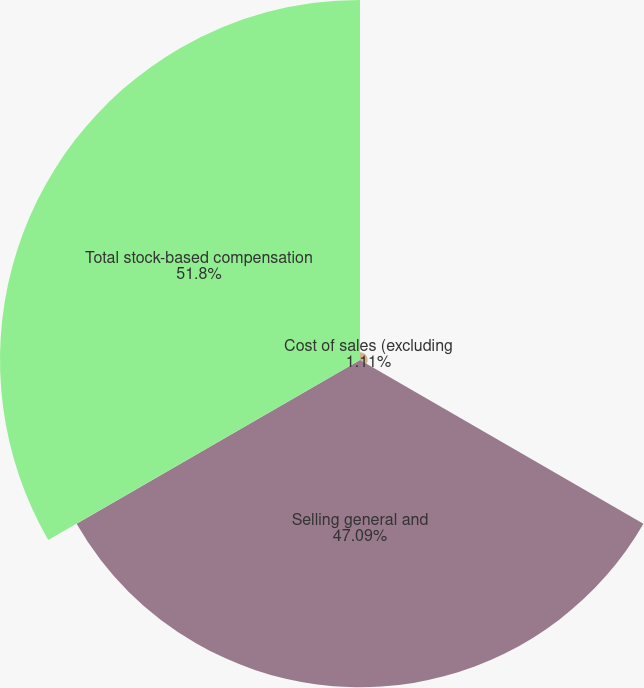Convert chart to OTSL. <chart><loc_0><loc_0><loc_500><loc_500><pie_chart><fcel>Cost of sales (excluding<fcel>Selling general and<fcel>Total stock-based compensation<nl><fcel>1.11%<fcel>47.09%<fcel>51.8%<nl></chart> 